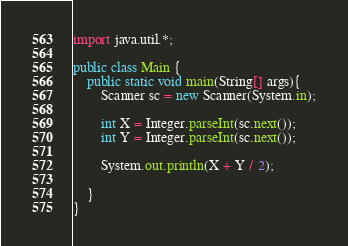<code> <loc_0><loc_0><loc_500><loc_500><_Java_>import java.util.*;

public class Main {
    public static void main(String[] args){
        Scanner sc = new Scanner(System.in);
        
        int X = Integer.parseInt(sc.next());
        int Y = Integer.parseInt(sc.next());
        
        System.out.println(X + Y / 2);
        
    }
}
</code> 